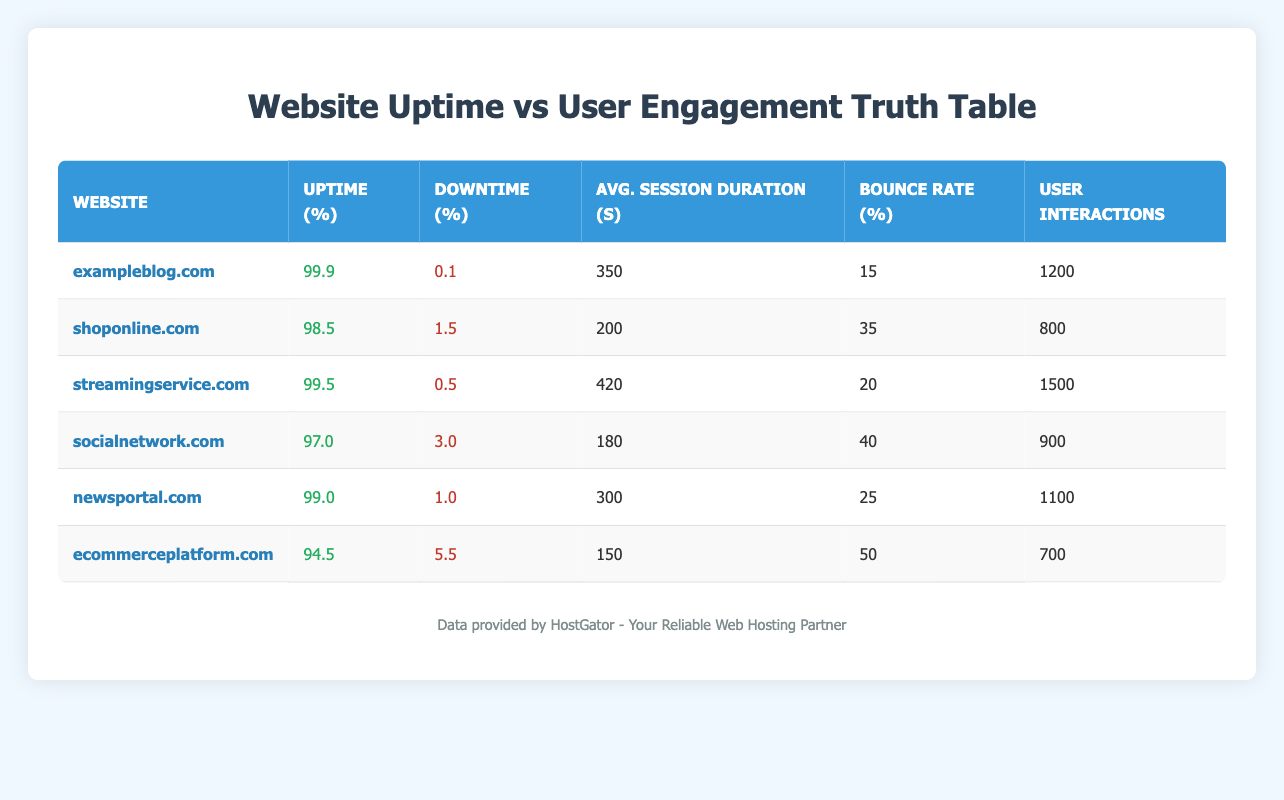What is the uptime percentage for streamingservice.com? The table shows a column labeled "Uptime (%)" which contains the uptime values for each website. For streamingservice.com, the value listed is 99.5.
Answer: 99.5 Which website has the lowest bounce rate? By examining the "Bounce Rate (%)" column, we find that exampleblog.com has the lowest bounce rate of 15%.
Answer: exampleblog.com What is the average session duration for ecommerceplatform.com? The "Avg. Session Duration (s)" column indicates that the average session duration for ecommerceplatform.com is 150 seconds.
Answer: 150 Which website has a higher user interaction: newsportal.com or socialnetwork.com? Looking at the "User Interactions" column for both websites, newsportal.com has 1100 interactions while socialnetwork.com has 900 interactions. Therefore, newsportal.com has a higher user interaction.
Answer: newsportal.com Is the downtime for exampleblog.com greater than the downtime for shoponline.com? In the "Downtime (%)" column, exampleblog.com has a downtime of 0.1% and shoponline.com has 1.5%. Since 0.1% is less than 1.5%, the statement is false.
Answer: No What is the total user interaction across all websites in the table? To find the total user interaction, we sum the user interactions: 1200 + 800 + 1500 + 900 + 1100 + 700 = 5200.
Answer: 5200 Does streamingservice.com have both a lower bounce rate and a higher average session duration compared to shoponline.com? Streamingservice.com has a bounce rate of 20% and an average session duration of 420 seconds. Shoponline.com has a bounce rate of 35% and an average session duration of 200 seconds. Since 20% < 35% (lower bounce rate) and 420 > 200 (higher duration), both conditions are met.
Answer: Yes What is the average uptime percentage of all listed websites? To calculate the average uptime, sum the uptime percentages: 99.9 + 98.5 + 99.5 + 97.0 + 99.0 + 94.5 = 588.4. Divide this by 6 (the number of websites): 588.4 / 6 ≈ 98.07.
Answer: 98.07 Which website has the highest downtime percentage? The "Downtime (%)" column shows that ecommerceplatform.com has the highest downtime at 5.5%.
Answer: ecommerceplatform.com 